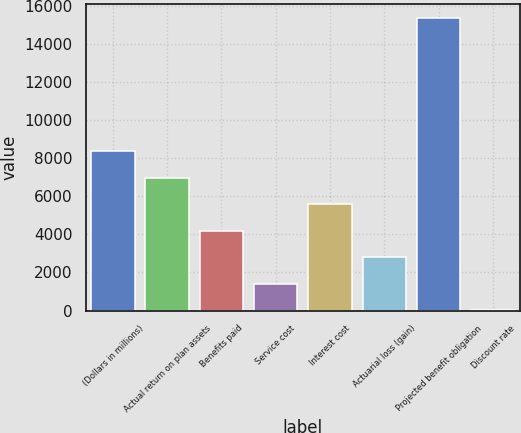<chart> <loc_0><loc_0><loc_500><loc_500><bar_chart><fcel>(Dollars in millions)<fcel>Actual return on plan assets<fcel>Benefits paid<fcel>Service cost<fcel>Interest cost<fcel>Actuarial loss (gain)<fcel>Projected benefit obligation<fcel>Discount rate<nl><fcel>8364.99<fcel>6971.73<fcel>4185.23<fcel>1398.71<fcel>5578.48<fcel>2791.97<fcel>15331.3<fcel>5.45<nl></chart> 